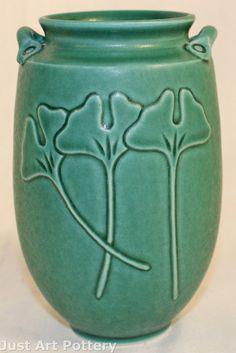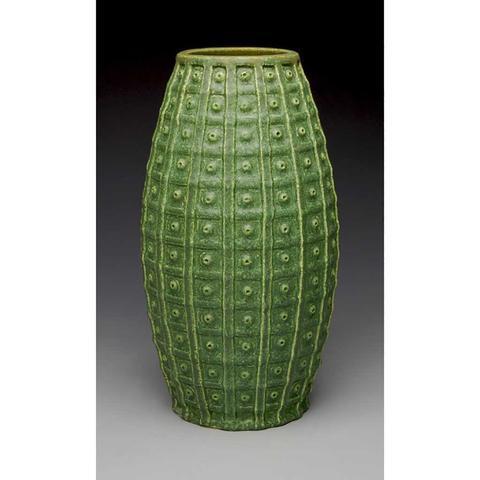The first image is the image on the left, the second image is the image on the right. Analyze the images presented: Is the assertion "One vase is mostly dark green while the other has a lot more lighter green on it." valid? Answer yes or no. No. The first image is the image on the left, the second image is the image on the right. Assess this claim about the two images: "All vases are the same green color with a drip effect, and no vases have handles.". Correct or not? Answer yes or no. No. 